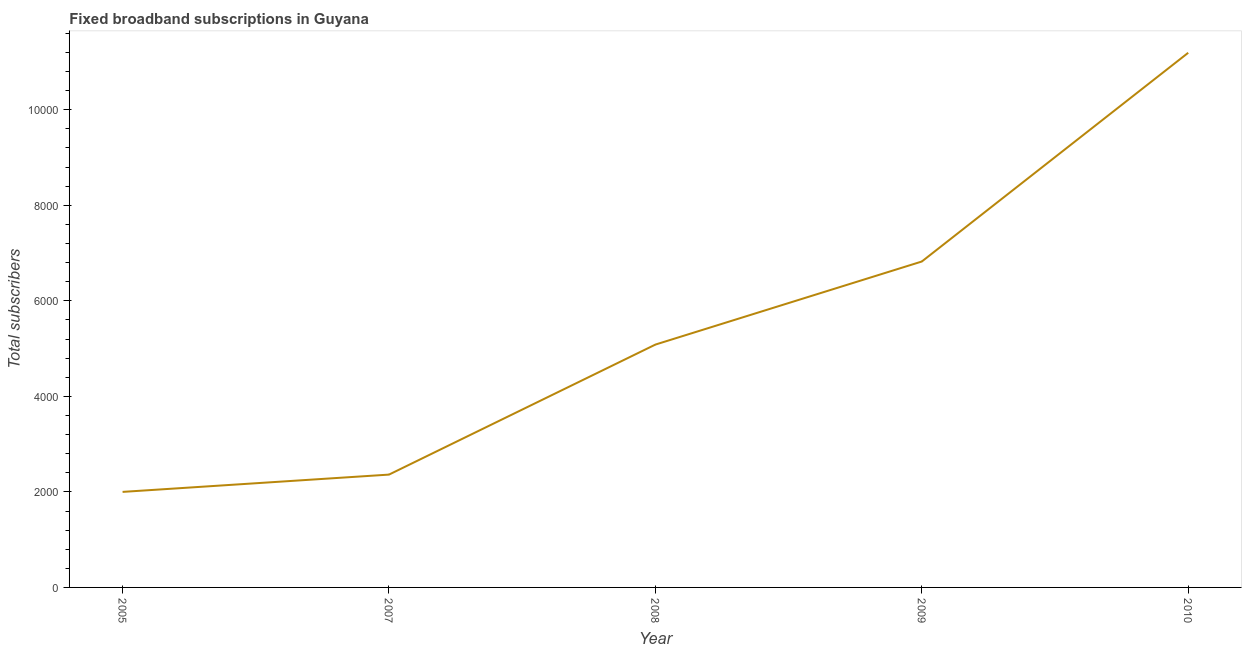What is the total number of fixed broadband subscriptions in 2010?
Provide a short and direct response. 1.12e+04. Across all years, what is the maximum total number of fixed broadband subscriptions?
Provide a succinct answer. 1.12e+04. Across all years, what is the minimum total number of fixed broadband subscriptions?
Offer a terse response. 2000. In which year was the total number of fixed broadband subscriptions maximum?
Provide a succinct answer. 2010. In which year was the total number of fixed broadband subscriptions minimum?
Your response must be concise. 2005. What is the sum of the total number of fixed broadband subscriptions?
Offer a terse response. 2.75e+04. What is the difference between the total number of fixed broadband subscriptions in 2009 and 2010?
Give a very brief answer. -4370. What is the average total number of fixed broadband subscriptions per year?
Make the answer very short. 5492.4. What is the median total number of fixed broadband subscriptions?
Your response must be concise. 5084. In how many years, is the total number of fixed broadband subscriptions greater than 9200 ?
Your answer should be compact. 1. What is the ratio of the total number of fixed broadband subscriptions in 2005 to that in 2010?
Provide a succinct answer. 0.18. What is the difference between the highest and the second highest total number of fixed broadband subscriptions?
Provide a succinct answer. 4370. What is the difference between the highest and the lowest total number of fixed broadband subscriptions?
Your answer should be very brief. 9193. In how many years, is the total number of fixed broadband subscriptions greater than the average total number of fixed broadband subscriptions taken over all years?
Offer a very short reply. 2. How many lines are there?
Your answer should be very brief. 1. Are the values on the major ticks of Y-axis written in scientific E-notation?
Your answer should be compact. No. Does the graph contain any zero values?
Your answer should be very brief. No. Does the graph contain grids?
Keep it short and to the point. No. What is the title of the graph?
Your answer should be compact. Fixed broadband subscriptions in Guyana. What is the label or title of the X-axis?
Make the answer very short. Year. What is the label or title of the Y-axis?
Your answer should be very brief. Total subscribers. What is the Total subscribers in 2005?
Give a very brief answer. 2000. What is the Total subscribers of 2007?
Offer a terse response. 2362. What is the Total subscribers in 2008?
Provide a short and direct response. 5084. What is the Total subscribers of 2009?
Make the answer very short. 6823. What is the Total subscribers of 2010?
Provide a succinct answer. 1.12e+04. What is the difference between the Total subscribers in 2005 and 2007?
Provide a short and direct response. -362. What is the difference between the Total subscribers in 2005 and 2008?
Ensure brevity in your answer.  -3084. What is the difference between the Total subscribers in 2005 and 2009?
Give a very brief answer. -4823. What is the difference between the Total subscribers in 2005 and 2010?
Keep it short and to the point. -9193. What is the difference between the Total subscribers in 2007 and 2008?
Offer a very short reply. -2722. What is the difference between the Total subscribers in 2007 and 2009?
Provide a succinct answer. -4461. What is the difference between the Total subscribers in 2007 and 2010?
Give a very brief answer. -8831. What is the difference between the Total subscribers in 2008 and 2009?
Offer a terse response. -1739. What is the difference between the Total subscribers in 2008 and 2010?
Provide a short and direct response. -6109. What is the difference between the Total subscribers in 2009 and 2010?
Keep it short and to the point. -4370. What is the ratio of the Total subscribers in 2005 to that in 2007?
Give a very brief answer. 0.85. What is the ratio of the Total subscribers in 2005 to that in 2008?
Ensure brevity in your answer.  0.39. What is the ratio of the Total subscribers in 2005 to that in 2009?
Your answer should be very brief. 0.29. What is the ratio of the Total subscribers in 2005 to that in 2010?
Offer a very short reply. 0.18. What is the ratio of the Total subscribers in 2007 to that in 2008?
Provide a short and direct response. 0.47. What is the ratio of the Total subscribers in 2007 to that in 2009?
Ensure brevity in your answer.  0.35. What is the ratio of the Total subscribers in 2007 to that in 2010?
Provide a short and direct response. 0.21. What is the ratio of the Total subscribers in 2008 to that in 2009?
Your response must be concise. 0.74. What is the ratio of the Total subscribers in 2008 to that in 2010?
Keep it short and to the point. 0.45. What is the ratio of the Total subscribers in 2009 to that in 2010?
Your response must be concise. 0.61. 